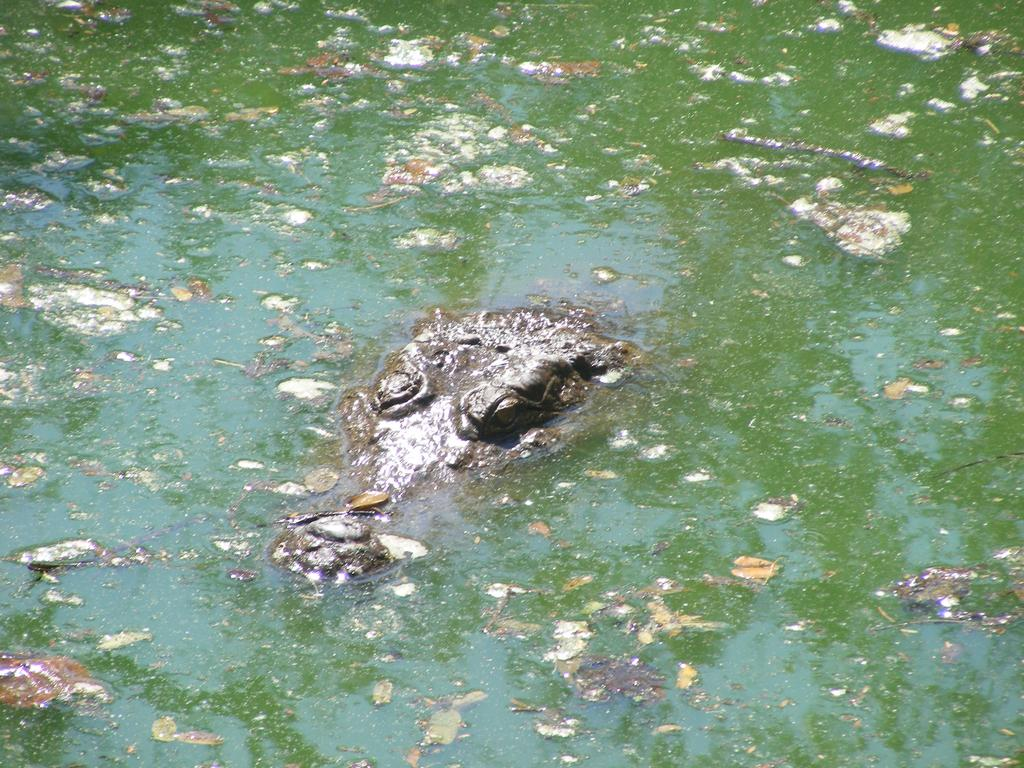What animal is present in the image? There is a crocodile in the image. Where is the crocodile located? The crocodile is in water. What is the color of the water in the image? The water is green in color. How many chairs are visible in the image? There are no chairs present in the image; it features a crocodile in green water. 